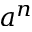<formula> <loc_0><loc_0><loc_500><loc_500>a ^ { n }</formula> 